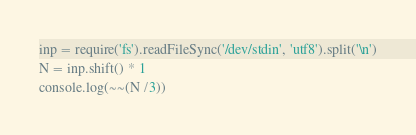Convert code to text. <code><loc_0><loc_0><loc_500><loc_500><_JavaScript_>inp = require('fs').readFileSync('/dev/stdin', 'utf8').split('\n')
N = inp.shift() * 1
console.log(~~(N /3))</code> 